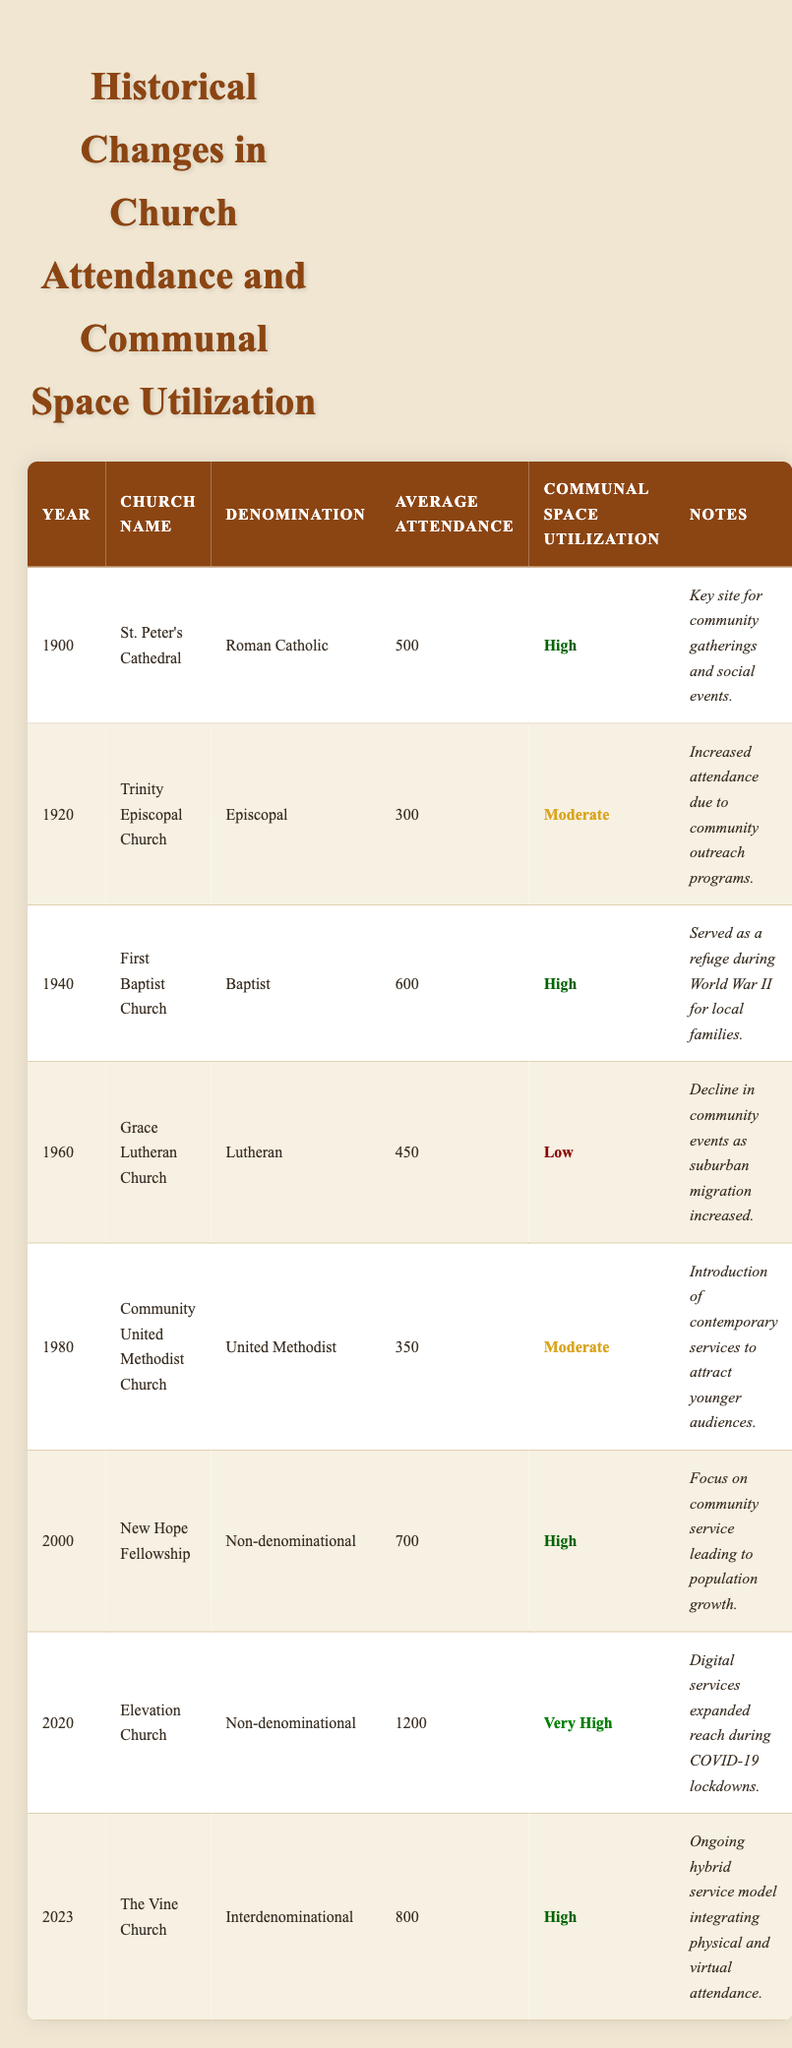What was the average attendance at St. Peter's Cathedral in 1900? The table states that the average attendance at St. Peter's Cathedral in 1900 was 500.
Answer: 500 How many churches had high communal space utilization in 2023? According to the table, there are 5 churches listed with high communal space utilization, including The Vine Church in 2023.
Answer: 5 Which church had the highest average attendance, and what was that attendance? The table indicates that Elevation Church had the highest average attendance of 1200 in 2020.
Answer: Elevation Church, 1200 Was there an increase in average attendance from 1980 to 2000? The average attendance in 1980 was 350, and in 2000 it was 700. Since 700 is greater than 350, there was an increase.
Answer: Yes What was the difference in average attendance between the years 1940 and 1960? The average attendance in 1940 was 600 while in 1960 it was 450. The difference is 600 - 450 = 150.
Answer: 150 How many churches utilized communal space at a very high level in 2020? The table shows that only one church, Elevation Church, had a very high utilization level in 2020.
Answer: 1 What was the trend in communal space utilization from 1960 to 2023? In 1960, communal space utilization was low. It increased to moderate in 1980, returned to high in 2000 and 2023, with a very high rating in 2020, demonstrating an overall upward trend.
Answer: Upward trend Which denomination had the lowest average attendance over the years provided? The table shows Grace Lutheran Church had the lowest attendance at 450 in 1960, indicating it was the least attended church during that year.
Answer: Lutheran How does average attendance in 2023 compare to that in 2000? The average attendance in 2023 was 800, while in 2000 it was 700. The comparison shows an increase of 100.
Answer: Increased by 100 What is the average attendance of the churches listed between 1900 and 2000? Adding the average attendances: 500 (1900) + 300 (1920) + 600 (1940) + 450 (1960) + 350 (1980) + 700 (2000) = 2900. There are 6 data points, so the average is 2900/6 = 483.33.
Answer: 483.33 